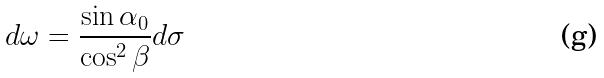Convert formula to latex. <formula><loc_0><loc_0><loc_500><loc_500>d \omega = \frac { \sin \alpha _ { 0 } } { \cos ^ { 2 } \beta } d \sigma</formula> 